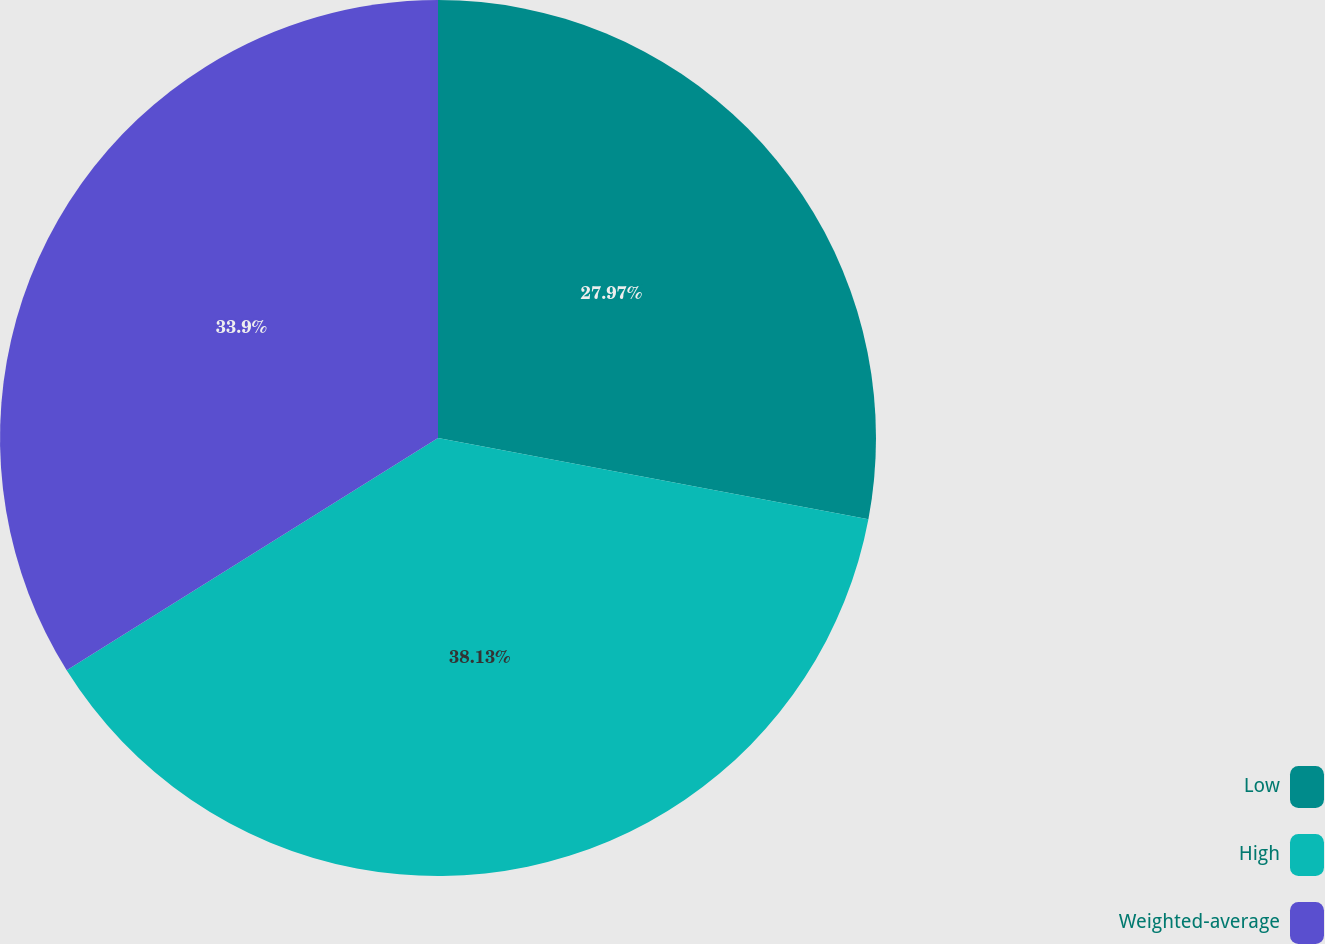Convert chart to OTSL. <chart><loc_0><loc_0><loc_500><loc_500><pie_chart><fcel>Low<fcel>High<fcel>Weighted-average<nl><fcel>27.97%<fcel>38.14%<fcel>33.9%<nl></chart> 